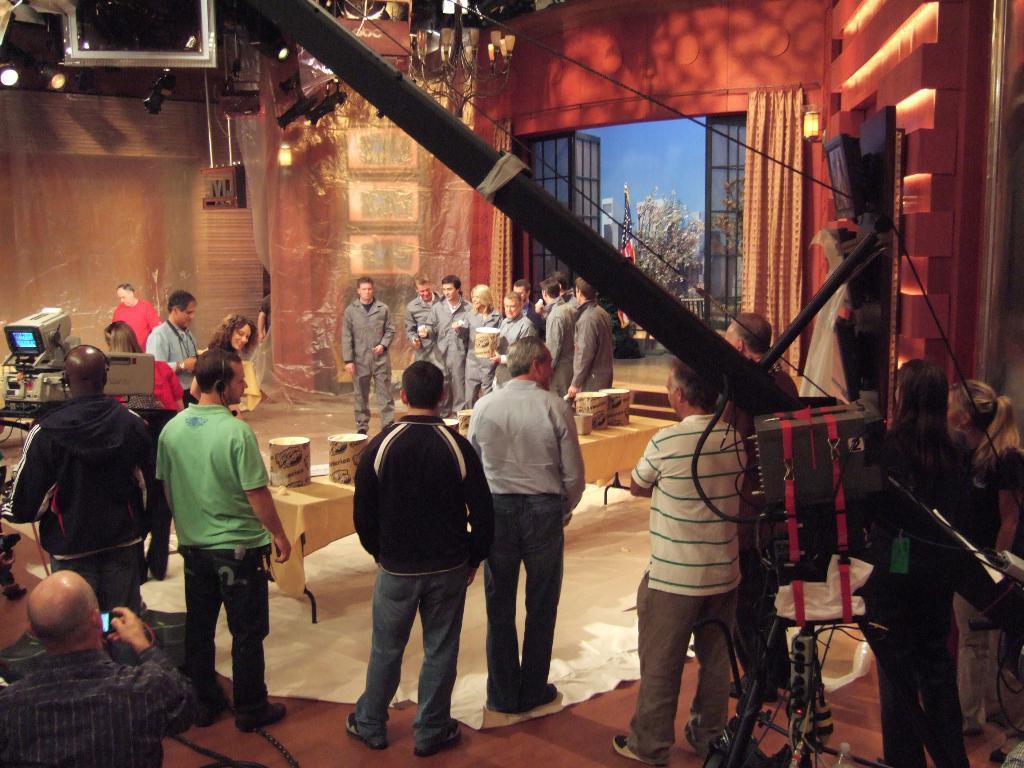Can you describe this image briefly? In the image there are many men standing all over the floor with a table in the middle and there is a camera with screen on the front, this seems to be a cinema shooting. 